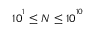<formula> <loc_0><loc_0><loc_500><loc_500>1 0 ^ { ^ { 1 } } \leq N \leq 1 0 ^ { ^ { 1 0 } }</formula> 